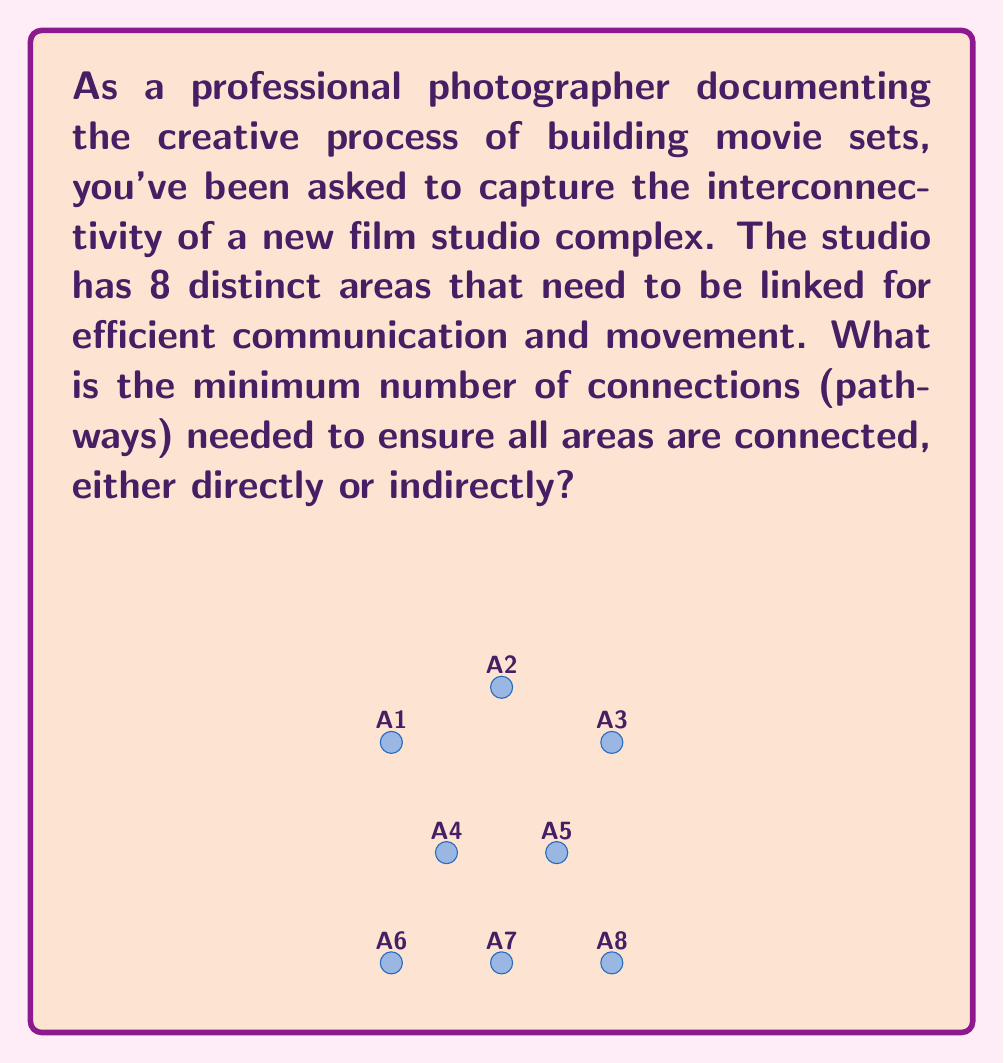Teach me how to tackle this problem. To solve this problem, we can use the concept of a minimum spanning tree from graph theory. In a connected graph with $n$ vertices:

1. A tree is a connected graph with no cycles.
2. A spanning tree includes all vertices of the graph.
3. The minimum spanning tree has the least number of edges while still connecting all vertices.

For a graph with $n$ vertices, the minimum number of edges needed to connect all vertices (i.e., the number of edges in a spanning tree) is always $n - 1$.

In this case:
1. We have 8 distinct areas (vertices) in the film studio complex.
2. Let $n = 8$ be the number of vertices.
3. The minimum number of connections (edges) needed = $n - 1 = 8 - 1 = 7$

This solution ensures that all areas are connected while using the minimum number of pathways, which is efficient for both the studio's layout and your photography documentation process.
Answer: 7 connections 